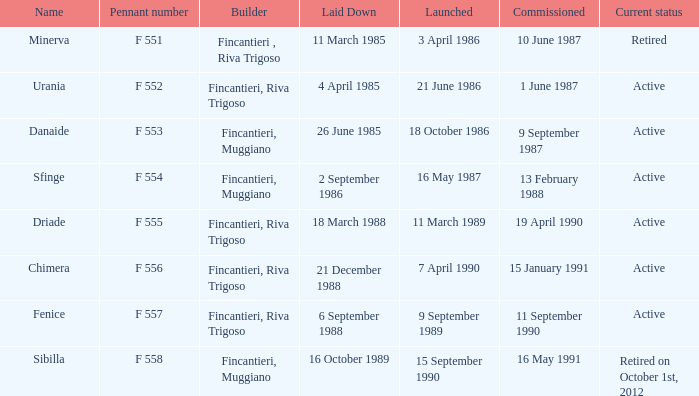Would you be able to parse every entry in this table? {'header': ['Name', 'Pennant number', 'Builder', 'Laid Down', 'Launched', 'Commissioned', 'Current status'], 'rows': [['Minerva', 'F 551', 'Fincantieri , Riva Trigoso', '11 March 1985', '3 April 1986', '10 June 1987', 'Retired'], ['Urania', 'F 552', 'Fincantieri, Riva Trigoso', '4 April 1985', '21 June 1986', '1 June 1987', 'Active'], ['Danaide', 'F 553', 'Fincantieri, Muggiano', '26 June 1985', '18 October 1986', '9 September 1987', 'Active'], ['Sfinge', 'F 554', 'Fincantieri, Muggiano', '2 September 1986', '16 May 1987', '13 February 1988', 'Active'], ['Driade', 'F 555', 'Fincantieri, Riva Trigoso', '18 March 1988', '11 March 1989', '19 April 1990', 'Active'], ['Chimera', 'F 556', 'Fincantieri, Riva Trigoso', '21 December 1988', '7 April 1990', '15 January 1991', 'Active'], ['Fenice', 'F 557', 'Fincantieri, Riva Trigoso', '6 September 1988', '9 September 1989', '11 September 1990', 'Active'], ['Sibilla', 'F 558', 'Fincantieri, Muggiano', '16 October 1989', '15 September 1990', '16 May 1991', 'Retired on October 1st, 2012']]} What builder launched the name minerva 3 April 1986. 